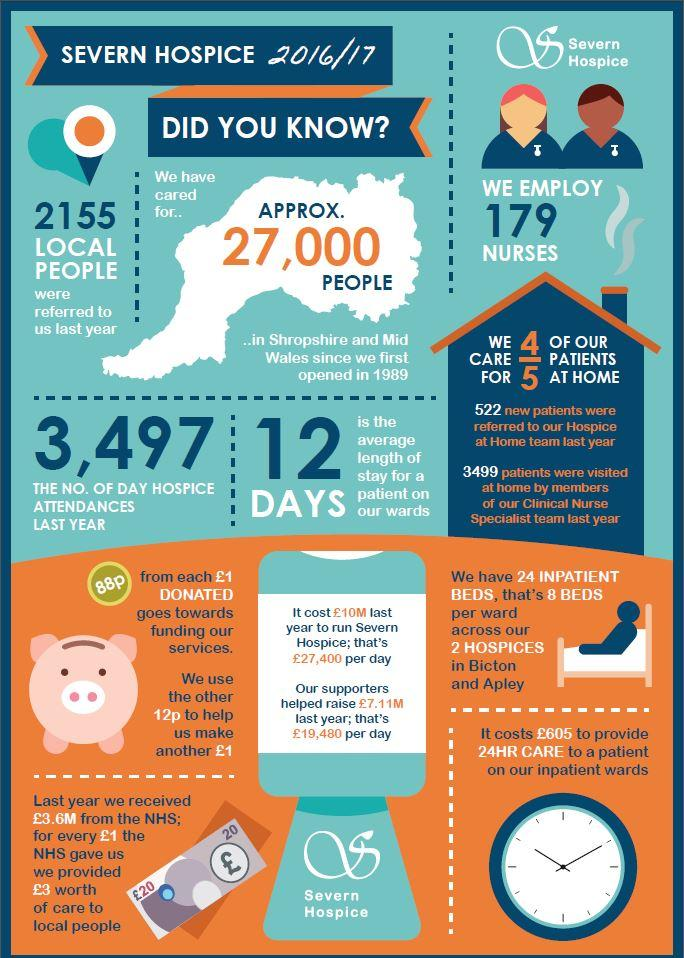Outline some significant characteristics in this image. The cost of providing 24-hour care to a patient in an inpatient ward is approximately 605 pounds. A total of 2155 local individuals were referred to the program. Approximately 4 out of 5 patients are cared for at home. For every £1 donated, 88p is used to fund services. The cost to run the hospital on a daily basis is approximately 27,400 pounds, 